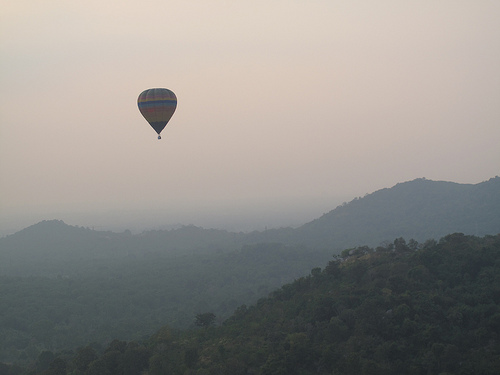<image>
Can you confirm if the balloon is behind the trees? No. The balloon is not behind the trees. From this viewpoint, the balloon appears to be positioned elsewhere in the scene. Is the balloon in the air? Yes. The balloon is contained within or inside the air, showing a containment relationship. Is there a balloon in the sky? Yes. The balloon is contained within or inside the sky, showing a containment relationship. 